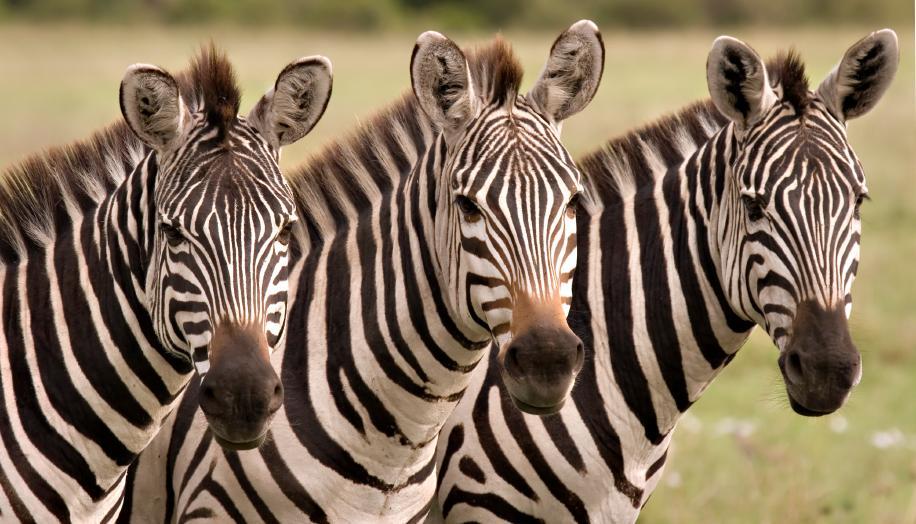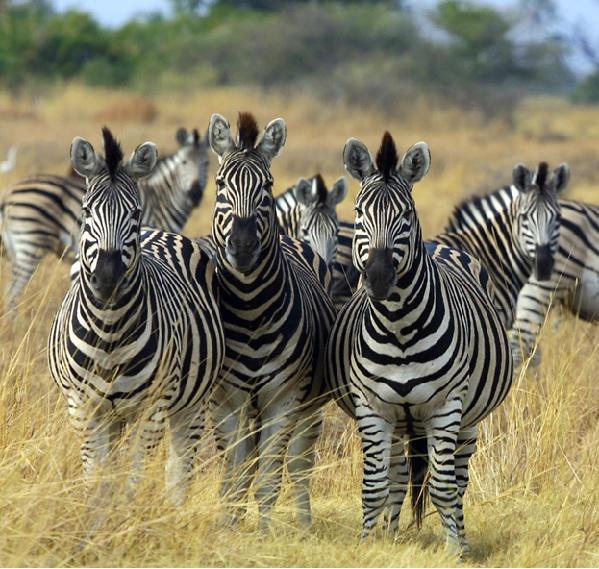The first image is the image on the left, the second image is the image on the right. Considering the images on both sides, is "Each image contains exactly three zebras, and one group of three zebras is turned away from the camera, with their rears showing." valid? Answer yes or no. No. The first image is the image on the left, the second image is the image on the right. Assess this claim about the two images: "The left and right image contains the same number of zebras facing forwards and backwards.". Correct or not? Answer yes or no. No. 